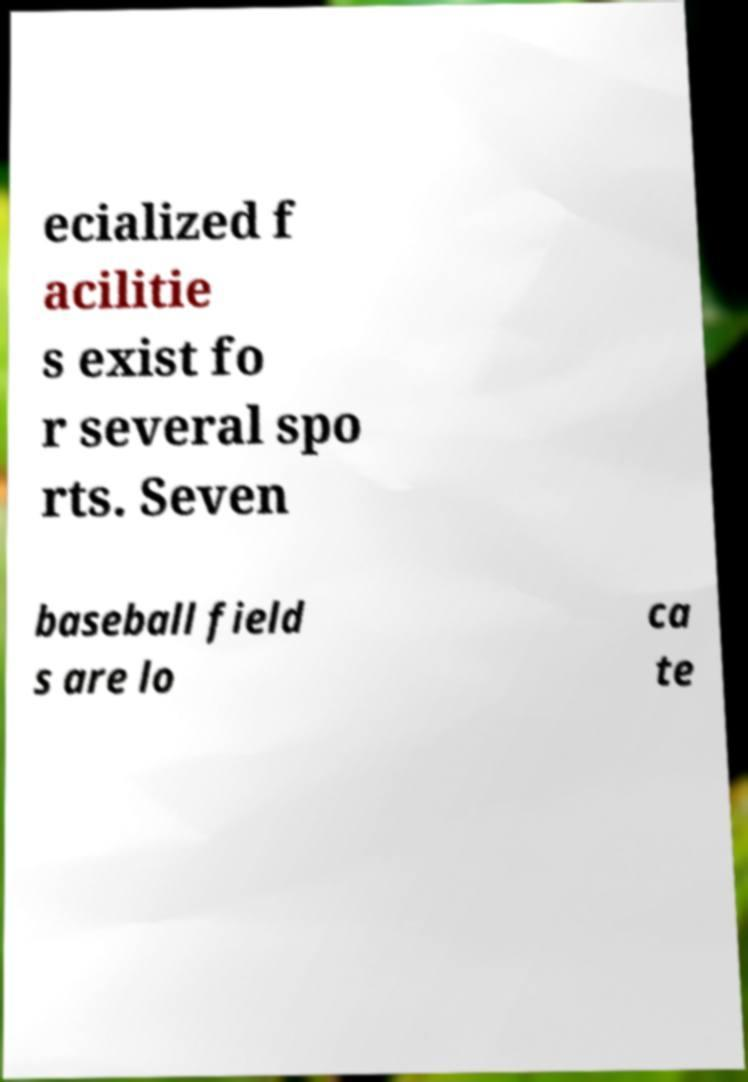For documentation purposes, I need the text within this image transcribed. Could you provide that? ecialized f acilitie s exist fo r several spo rts. Seven baseball field s are lo ca te 